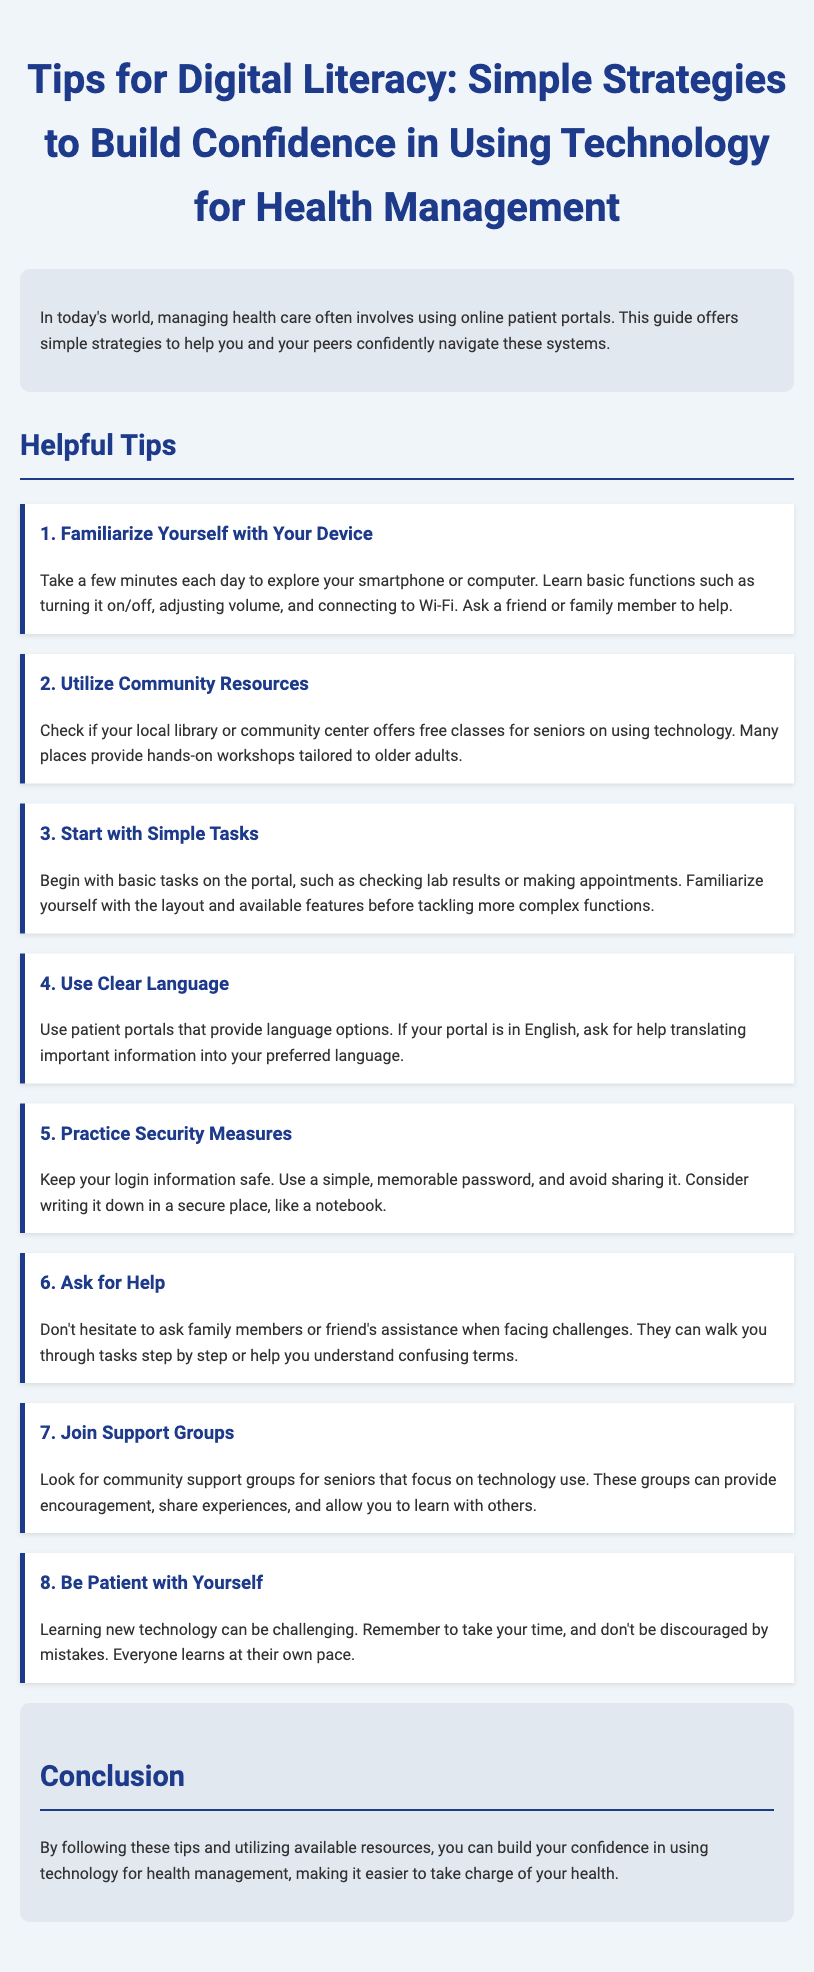What is the title of the document? The title is presented at the top of the document and indicates the main topic covered.
Answer: Tips for Digital Literacy: Simple Strategies to Build Confidence in Using Technology for Health Management How many helpful tips are provided? The document lists a specific number of tips under the "Helpful Tips" section.
Answer: Eight What is the first tip mentioned? The first tip is emphasized with a specific heading and provides guidance on a basic action.
Answer: Familiarize Yourself with Your Device Which section discusses community resources? This section focuses on resources available to help seniors learn technology.
Answer: Utilize Community Resources What should you do to practice security measures? This question looks for recommendations regarding security in the context of using online portals.
Answer: Keep your login information safe Why is it important to ask for help? This question examines the rationale given for seeking assistance when using technology.
Answer: To get help understanding confusing terms What is emphasized regarding learning new technology? This highlights a piece of advice reflecting a supportive approach to learning.
Answer: Be Patient with Yourself What type of groups should seniors consider joining? This question identifies a resource for learning and support mentioned in the document.
Answer: Support Groups 